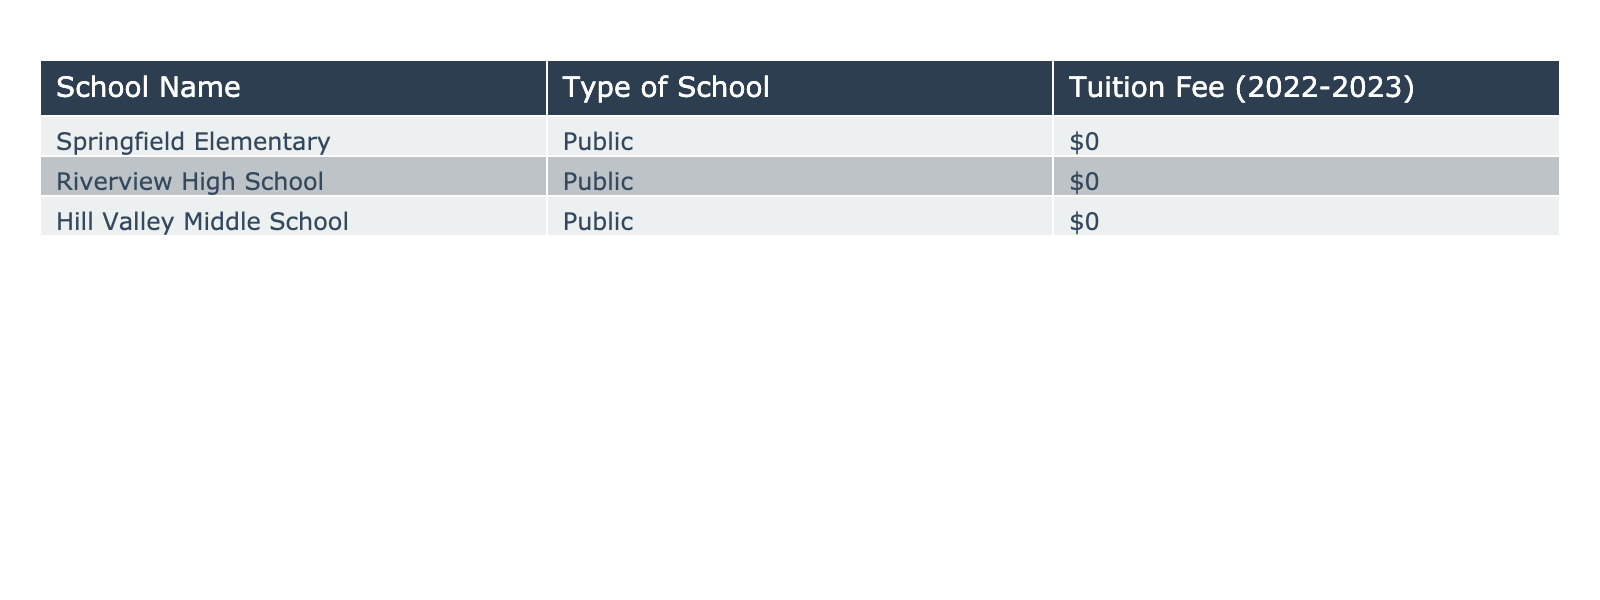What is the tuition fee for Springfield Elementary? According to the table, the tuition fee for Springfield Elementary is $0.
Answer: $0 How many schools listed in the table are public schools? There are three schools listed, and all of them are public schools, as indicated in the "Type of School" column.
Answer: 3 Is there any public school that charges tuition fees? The table shows that all public schools listed have a tuition fee of $0, meaning none charge tuition fees.
Answer: No What is the total tuition fee for all public schools combined? Since each public school has a tuition fee of $0, adding these fees together (0 + 0 + 0) gives a total of $0.
Answer: $0 Are there any private schools mentioned in the table? The table contains only public schools, as shown in the "Type of School" column, so there are no private schools listed.
Answer: No What is the average tuition fee of public schools in the table? The tuition fees for public schools are all $0, and with three schools, the average is calculated as (0 + 0 + 0) / 3 = 0.
Answer: $0 If a private school were to be added that charges $10,000, what would the new average tuition fee be? Currently, the total for public schools is $0 (from three schools). Adding a private school with a tuition fee of $10,000 gives a new total of $10,000. For four schools, the new average is $10,000 / 4, which equals $2,500.
Answer: $2,500 What is the difference in tuition fees between the public schools listed? All public schools have the same tuition fee of $0, so the difference between the highest and lowest tuition fee is 0 - 0, which results in $0.
Answer: $0 How many schools have a tuition fee of $0? All three schools listed have a tuition fee of $0, as shown in the table.
Answer: 3 